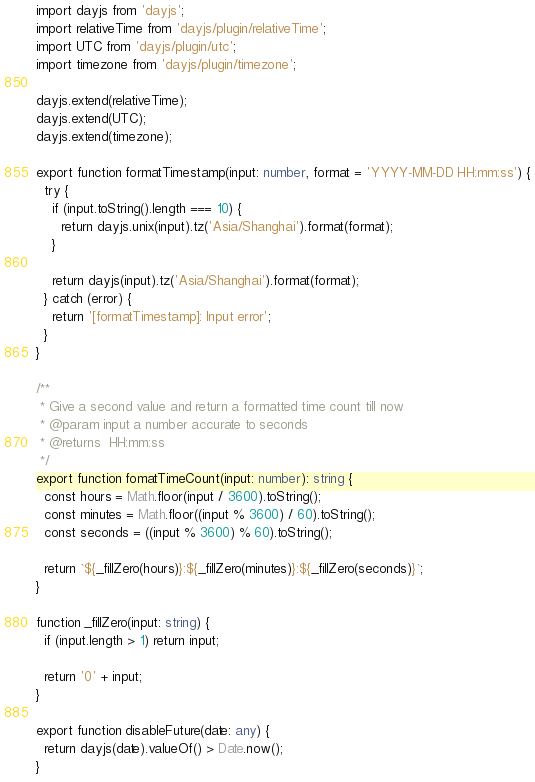<code> <loc_0><loc_0><loc_500><loc_500><_TypeScript_>import dayjs from 'dayjs';
import relativeTime from 'dayjs/plugin/relativeTime';
import UTC from 'dayjs/plugin/utc';
import timezone from 'dayjs/plugin/timezone';

dayjs.extend(relativeTime);
dayjs.extend(UTC);
dayjs.extend(timezone);

export function formatTimestamp(input: number, format = 'YYYY-MM-DD HH:mm:ss') {
  try {
    if (input.toString().length === 10) {
      return dayjs.unix(input).tz('Asia/Shanghai').format(format);
    }

    return dayjs(input).tz('Asia/Shanghai').format(format);
  } catch (error) {
    return '[formatTimestamp]: Input error';
  }
}

/**
 * Give a second value and return a formatted time count till now
 * @param input a number accurate to seconds
 * @returns  HH:mm:ss
 */
export function fomatTimeCount(input: number): string {
  const hours = Math.floor(input / 3600).toString();
  const minutes = Math.floor((input % 3600) / 60).toString();
  const seconds = ((input % 3600) % 60).toString();

  return `${_fillZero(hours)}:${_fillZero(minutes)}:${_fillZero(seconds)}`;
}

function _fillZero(input: string) {
  if (input.length > 1) return input;

  return '0' + input;
}

export function disableFuture(date: any) {
  return dayjs(date).valueOf() > Date.now();
}
</code> 